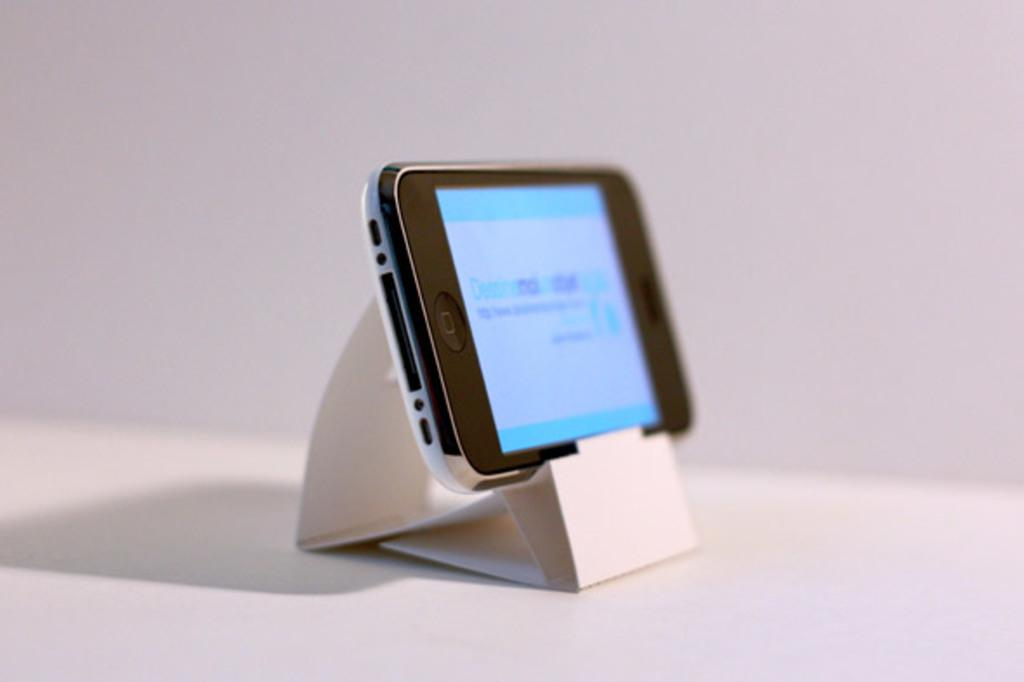What is the main object in the image? There is a mobile in the image. Where is the mobile located? The mobile is placed on a mobile stand. What is visible at the bottom of the image? There is a floor visible at the bottom of the image. What can be seen in the background of the image? There is a wall in the background of the image. What type of cheese is being served on the table in the image? There is no cheese or table present in the image; it features a mobile on a mobile stand. What type of food is being prepared in the office in the image? There is no office or food preparation visible in the image; it only shows a mobile on a mobile stand. 